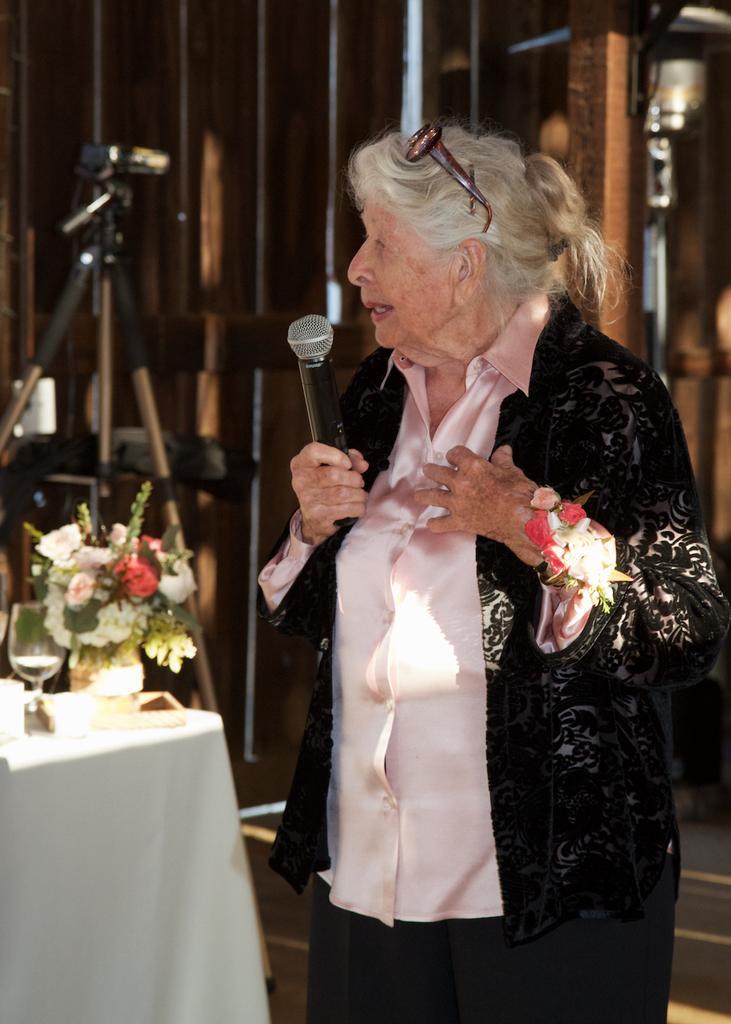Describe this image in one or two sentences. In the middle of the image a woman is standing and holding a microphone. Bottom left side of the image there is a table on the table there is a glass and a flower pot. 